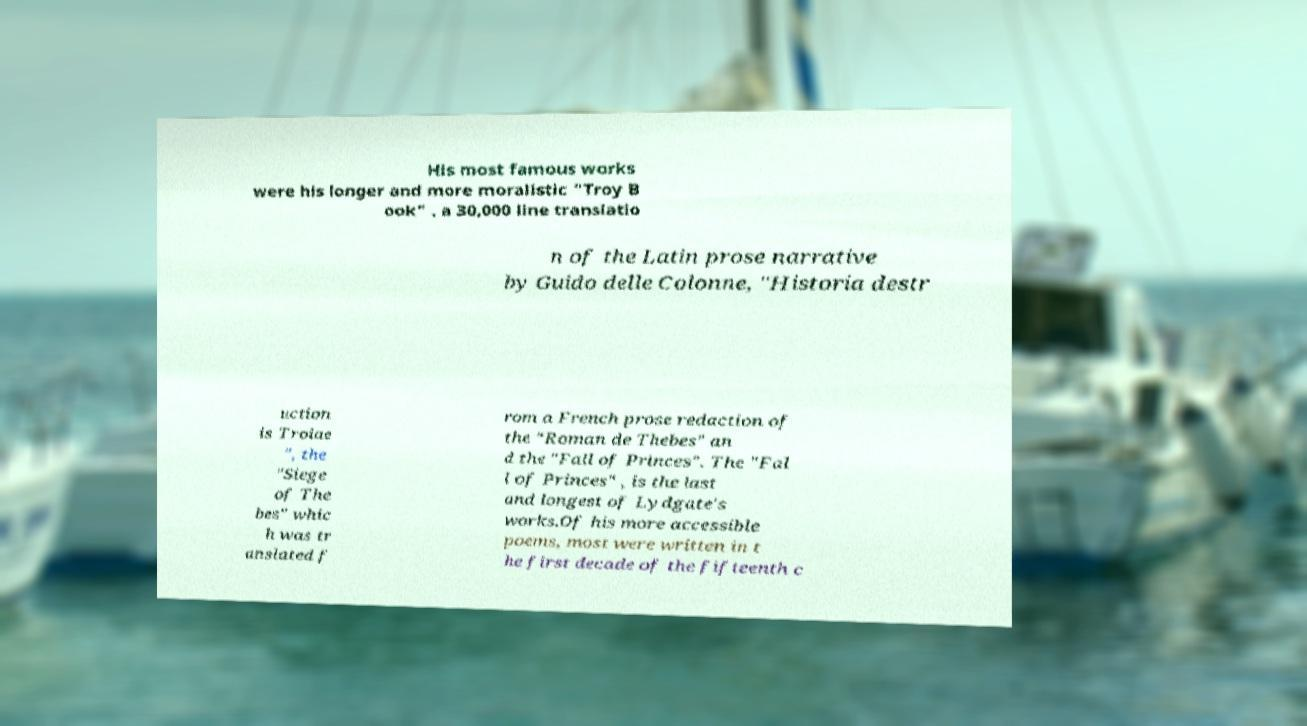I need the written content from this picture converted into text. Can you do that? His most famous works were his longer and more moralistic "Troy B ook" , a 30,000 line translatio n of the Latin prose narrative by Guido delle Colonne, "Historia destr uction is Troiae ", the "Siege of The bes" whic h was tr anslated f rom a French prose redaction of the "Roman de Thebes" an d the "Fall of Princes". The "Fal l of Princes" , is the last and longest of Lydgate's works.Of his more accessible poems, most were written in t he first decade of the fifteenth c 